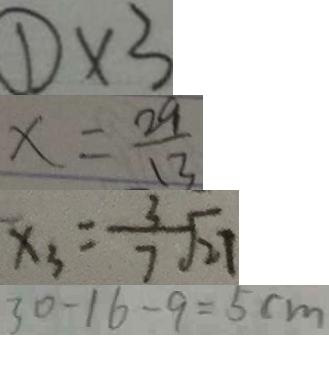<formula> <loc_0><loc_0><loc_500><loc_500>\textcircled { 1 } \times 3 
 x = \frac { 2 9 } { 1 3 } 
 x _ { 3 } = \frac { 3 } { 7 } \sqrt { 2 7 } 
 3 0 - 1 6 - 9 = 5 c m</formula> 